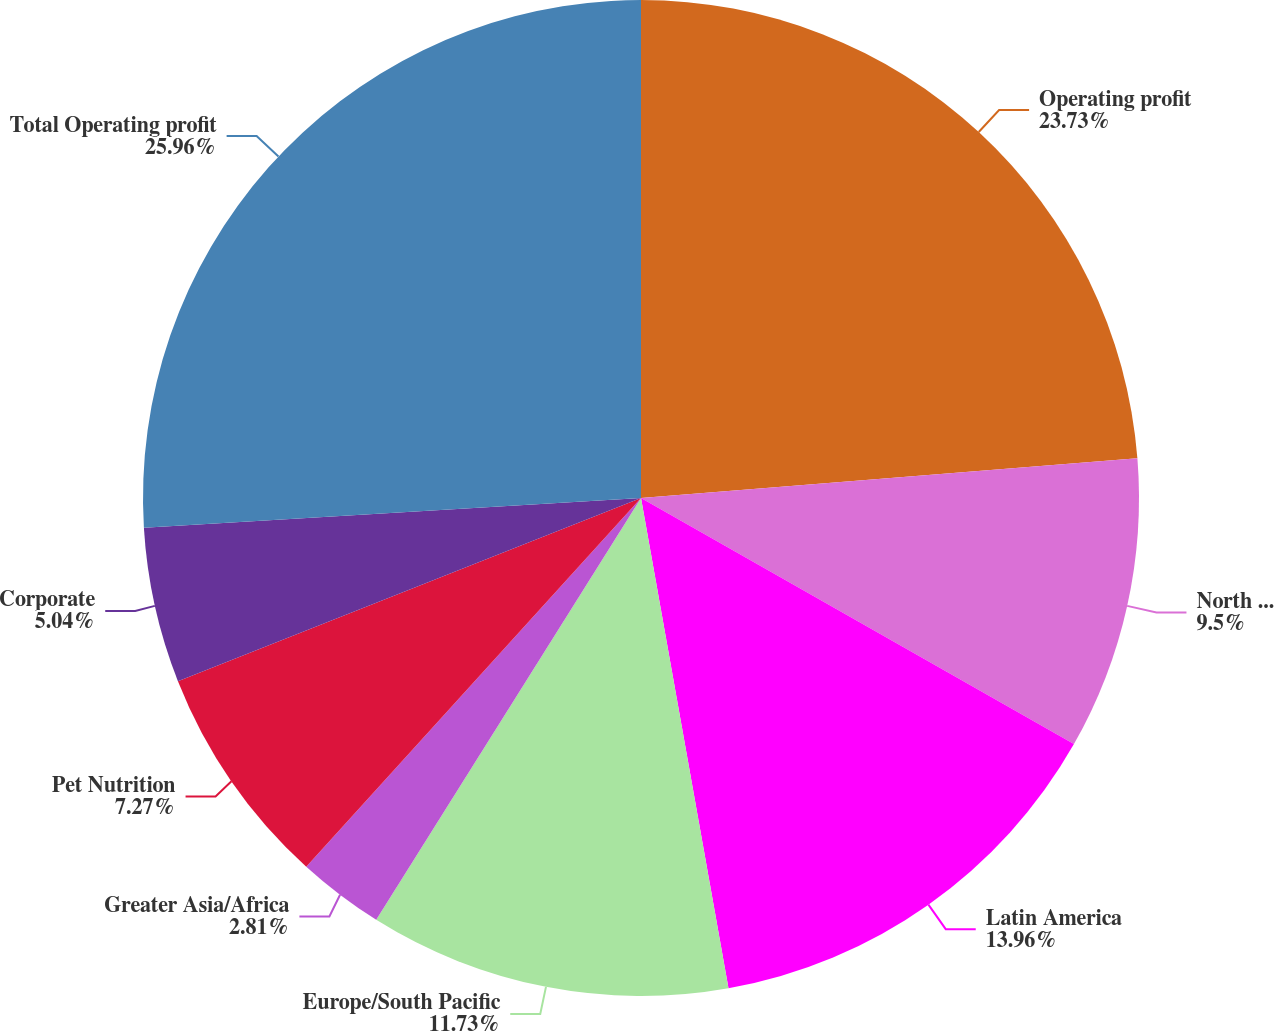<chart> <loc_0><loc_0><loc_500><loc_500><pie_chart><fcel>Operating profit<fcel>North America<fcel>Latin America<fcel>Europe/South Pacific<fcel>Greater Asia/Africa<fcel>Pet Nutrition<fcel>Corporate<fcel>Total Operating profit<nl><fcel>23.72%<fcel>9.5%<fcel>13.96%<fcel>11.73%<fcel>2.81%<fcel>7.27%<fcel>5.04%<fcel>25.95%<nl></chart> 